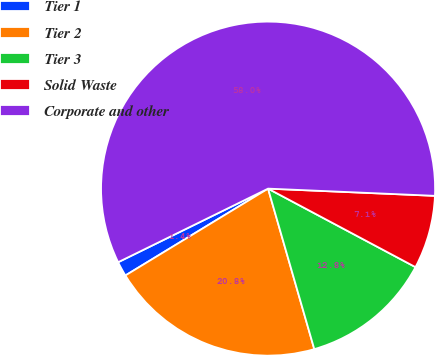Convert chart to OTSL. <chart><loc_0><loc_0><loc_500><loc_500><pie_chart><fcel>Tier 1<fcel>Tier 2<fcel>Tier 3<fcel>Solid Waste<fcel>Corporate and other<nl><fcel>1.44%<fcel>20.76%<fcel>12.75%<fcel>7.1%<fcel>57.95%<nl></chart> 